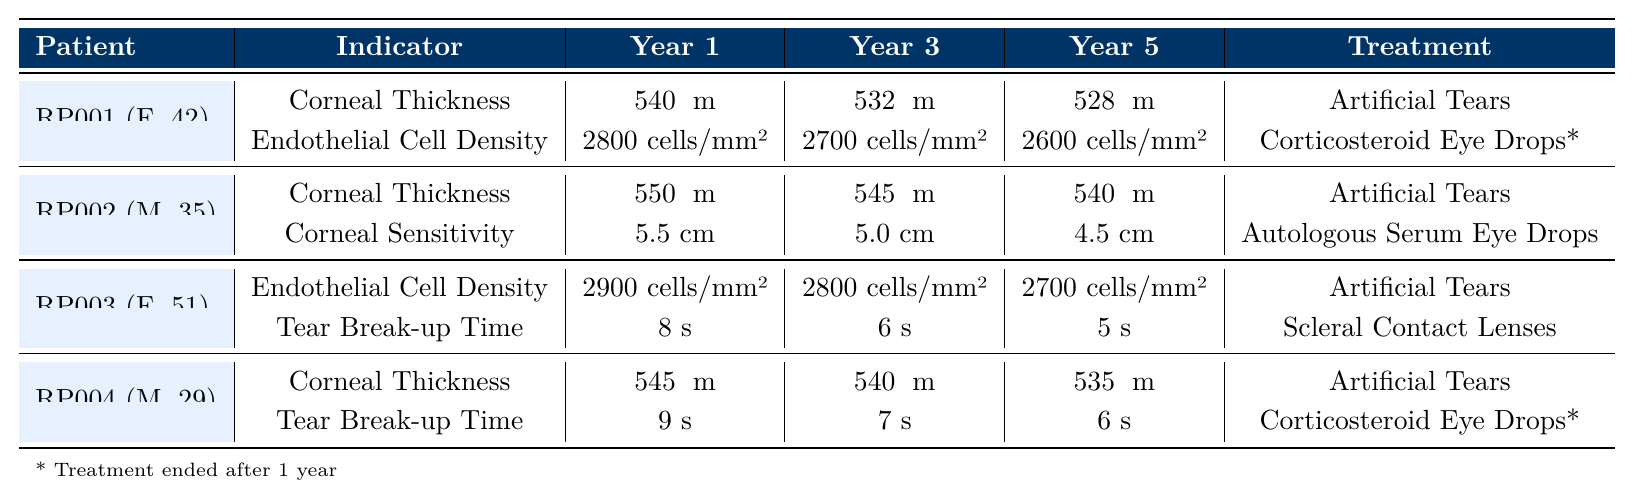What is the corneal thickness for patient RP001 in year 5? Patient RP001 has a corneal thickness of 528 μm in year 5 as indicated in the table.
Answer: 528 μm What was the initial endothelial cell density for patient RP003 in year 1? Patient RP003's endothelial cell density in year 1 is 2900 cells/mm² as shown in the table.
Answer: 2900 cells/mm² Did patient RP002 experience an increase in corneal thickness over years 1 to 5? Patient RP002's corneal thickness decreased from 550 μm in year 1 to 540 μm in year 5, indicating a decline, not an increase.
Answer: No What is the average tear break-up time for patient RP004 over the 5 years? The tear break-up times for patient RP004 across 5 years are 9 s, 8 s, 7 s, 7 s, and 6 s. The sum is 9 + 8 + 7 + 7 + 6 = 37 s. Dividing by 5 gives an average of 37 s / 5 = 7.4 s.
Answer: 7.4 s Which treatment did patient RP001 start first? Patient RP001 began treatment with Artificial Tears on March 20, 2018, as noted in the patient treatments section of the table.
Answer: Artificial Tears By how much did the endothelial cell density decrease for patient RP001 from year 1 to year 5? Patient RP001's endothelial cell density decreased from 2800 cells/mm² in year 1 to 2600 cells/mm² in year 5. The change is 2800 - 2600 = 200 cells/mm².
Answer: 200 cells/mm² What treatment did patient RP003 NOT receive? Patient RP003 did not receive Corticosteroid Eye Drops, as it is not listed among the treatments provided to this patient in the table.
Answer: Corticosteroid Eye Drops Is the corneal sensitivity for patient RP002 lower in year 5 than in year 1? Yes, patient RP002's corneal sensitivity decreased from 5.5 cm in year 1 to 4.5 cm in year 5, indicating a decline over time.
Answer: Yes What was the difference in corneal thickness between patient RP004 and patient RP002 in year 3? Patient RP004 had a corneal thickness of 540 μm in year 3, while patient RP002 had a thickness of 545 μm. The difference is 545 - 540 = 5 μm.
Answer: 5 μm In year 2, which patient had the lowest endothelial cell density? In year 2, patient RP001 had an endothelial cell density of 2750 cells/mm², while patients RP002, RP003, and RP004 had densities of 548, 2850, and 542, respectively. Hence, RP001 had the lowest.
Answer: RP001 What percentage decrease did the corneal thickness experience from year 1 to year 4 for patient RP001? Patient RP001's corneal thickness decreased from 540 μm in year 1 to 530 μm in year 4. The difference is 540 - 530 = 10 μm. The percentage decrease is (10 / 540) * 100 = 1.85%.
Answer: 1.85% 